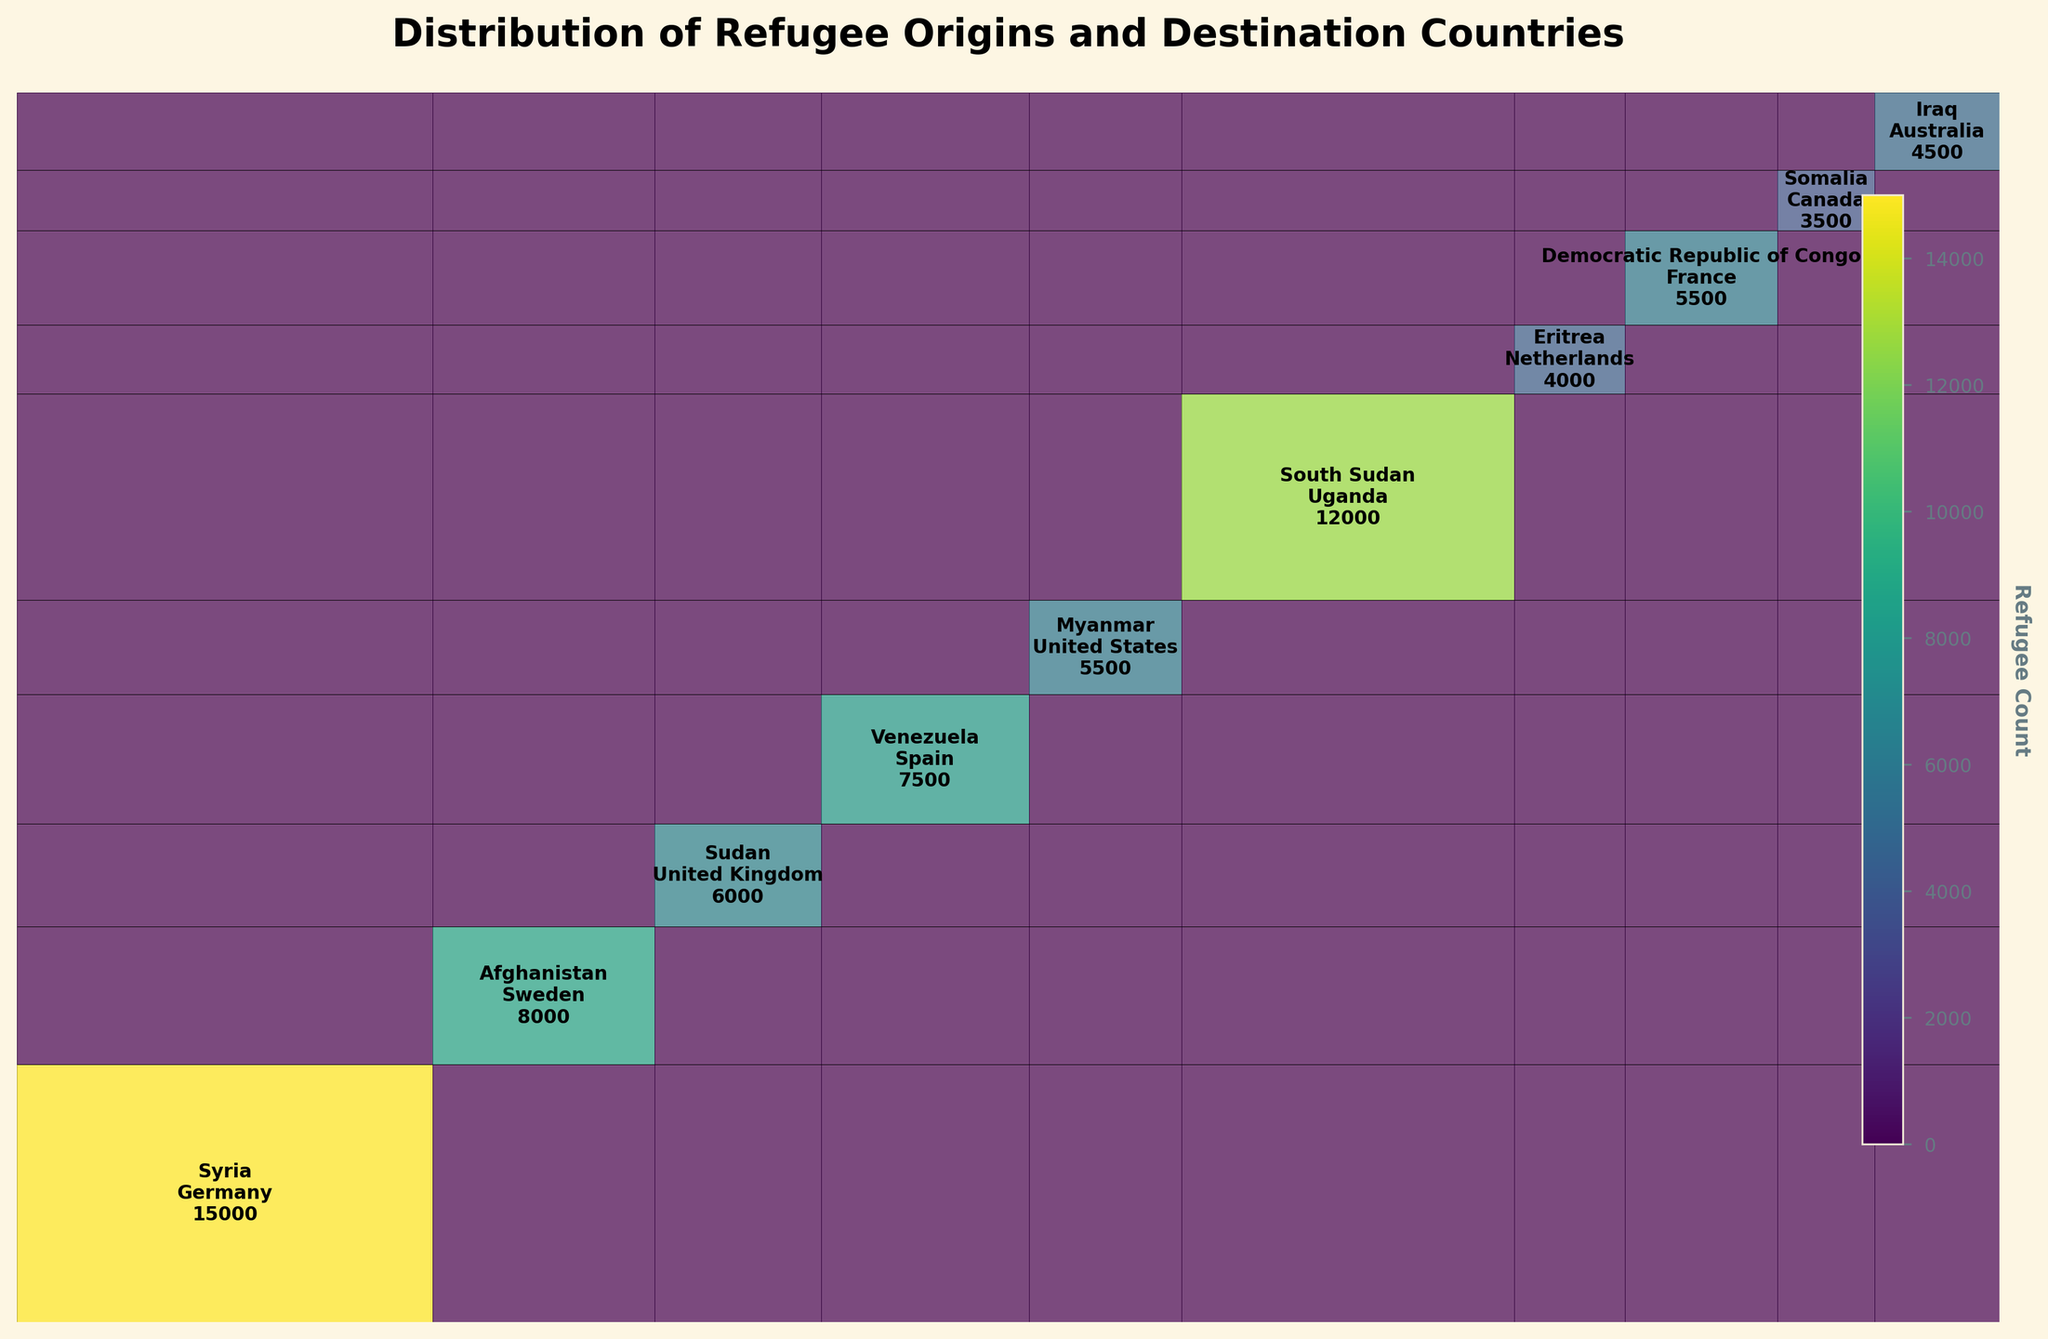What is the title of the figure? The title is usually displayed at the top of the figure. By reading the title provided above the plot, we can determine the title easily.
Answer: Distribution of Refugee Origins and Destination Countries Which refugee origin has the largest representation in Germany? To answer this, look for the section in the figure where Germany intersects with the various origins and identify the biggest block.
Answer: Syria What is the total number of refugees from South Sudan shown in the plot? Adding up the number of refugees from South Sudan going to various destinations will give the total. Here, it’s stated directly in the data.
Answer: 12000 Which destination country receives the smallest number of refugees from Somalia? By examining the block for Somalia and comparing it to other countries' blocks in size, this can be determined.
Answer: Canada How many refugees from Afghanistan prefer Sweden as their destination? Find the intersection in the plot where refugees from Afghanistan align with Sweden and read off the number.
Answer: 8000 Compare the number of refugees from Venezuela to Spain with those from Iraq to Australia. Which is higher and by how much? Reviewing the two blocks in the mosaic plot where Venezuela intersects with Spain and Iraq intersects with Australia, compare the numbers and compute the difference.
Answer: Venezuela to Spain is higher by 3000 Which origin-destination pair represents the smallest segment in the plot? By observing the smallest block in the mosaic plot in terms of area, we can identify the smallest segment.
Answer: Somalia to Canada What is the combined number of refugees from Syria and South Sudan? Adding the number of refugees from Syria (15000) and South Sudan (12000) gives the combined total.
Answer: 27000 How many more refugees from Democratic Republic of Congo go to France compared to those from Myanmar to the United States? Subtract the number of Myanmar refugees to the United States from the number of Democratic Republic of Congo refugees to France.
Answer: 1000 Which destination country hosts the highest total number of refugees from all origins combined, as represented in the plot? Summing the widths of all segments for each destination country and identifying the largest sum reveals the country hosting the highest total.
Answer: Germany 